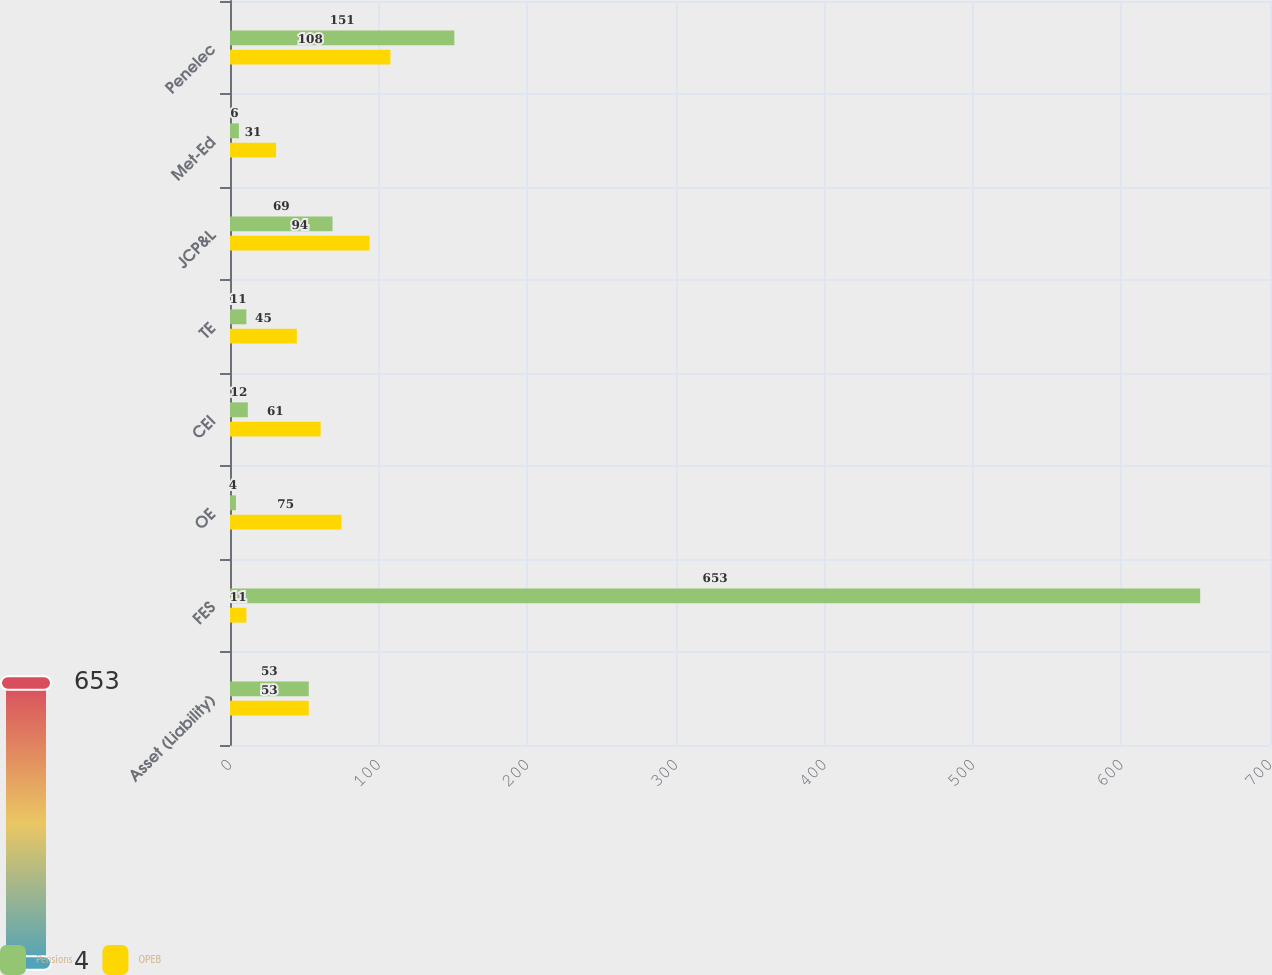Convert chart to OTSL. <chart><loc_0><loc_0><loc_500><loc_500><stacked_bar_chart><ecel><fcel>Asset (Liability)<fcel>FES<fcel>OE<fcel>CEI<fcel>TE<fcel>JCP&L<fcel>Met-Ed<fcel>Penelec<nl><fcel>Pensions<fcel>53<fcel>653<fcel>4<fcel>12<fcel>11<fcel>69<fcel>6<fcel>151<nl><fcel>OPEB<fcel>53<fcel>11<fcel>75<fcel>61<fcel>45<fcel>94<fcel>31<fcel>108<nl></chart> 